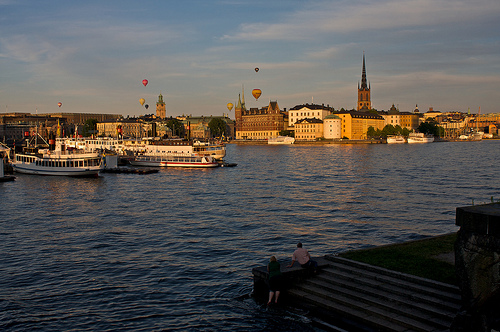<image>
Is the ship above the water? No. The ship is not positioned above the water. The vertical arrangement shows a different relationship. 